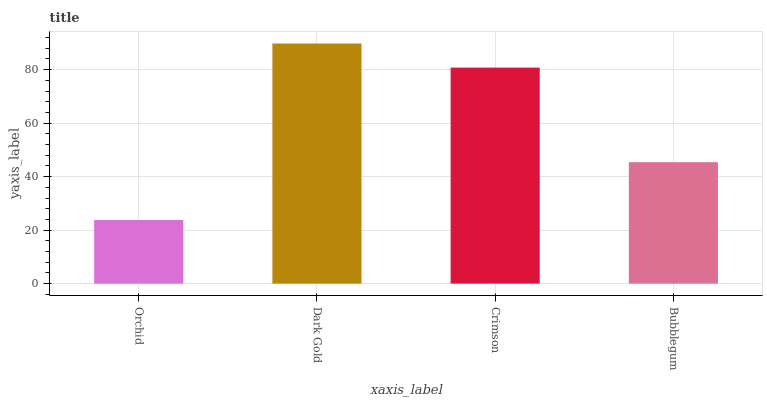Is Orchid the minimum?
Answer yes or no. Yes. Is Dark Gold the maximum?
Answer yes or no. Yes. Is Crimson the minimum?
Answer yes or no. No. Is Crimson the maximum?
Answer yes or no. No. Is Dark Gold greater than Crimson?
Answer yes or no. Yes. Is Crimson less than Dark Gold?
Answer yes or no. Yes. Is Crimson greater than Dark Gold?
Answer yes or no. No. Is Dark Gold less than Crimson?
Answer yes or no. No. Is Crimson the high median?
Answer yes or no. Yes. Is Bubblegum the low median?
Answer yes or no. Yes. Is Dark Gold the high median?
Answer yes or no. No. Is Orchid the low median?
Answer yes or no. No. 